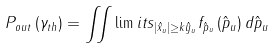<formula> <loc_0><loc_0><loc_500><loc_500>{ P _ { o u t } } \left ( { { \gamma _ { t h } } } \right ) = \iint \lim i t s _ { \left | { { { \hat { x } } _ { u } } } \right | \geq k { { \hat { y } } _ { u } } } { f _ { \hat { p } _ { u } } } \left ( \hat { p } _ { u } \right ) d { \hat { p } _ { u } }</formula> 